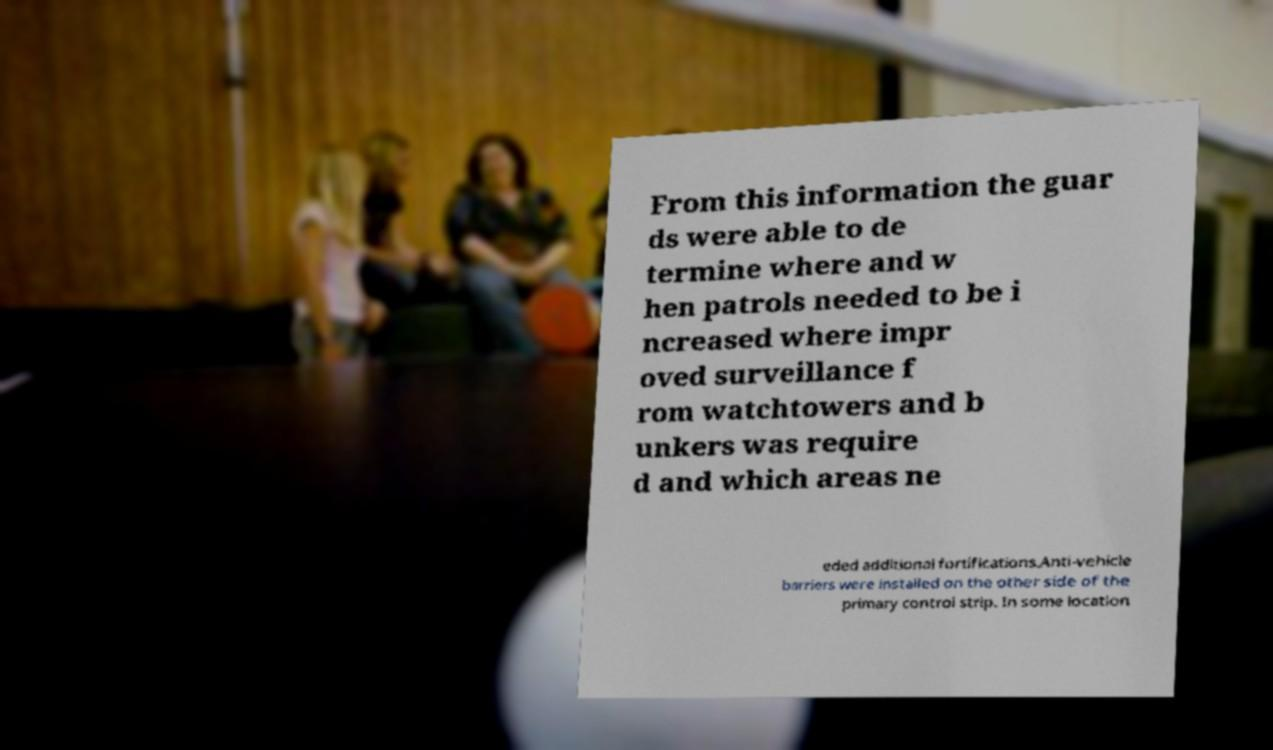I need the written content from this picture converted into text. Can you do that? From this information the guar ds were able to de termine where and w hen patrols needed to be i ncreased where impr oved surveillance f rom watchtowers and b unkers was require d and which areas ne eded additional fortifications.Anti-vehicle barriers were installed on the other side of the primary control strip. In some location 